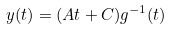Convert formula to latex. <formula><loc_0><loc_0><loc_500><loc_500>y ( t ) = ( A t + C ) g ^ { - 1 } ( t )</formula> 